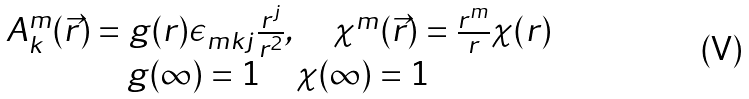Convert formula to latex. <formula><loc_0><loc_0><loc_500><loc_500>\begin{array} { c c } A _ { k } ^ { m } ( \vec { r } ) = g ( r ) \epsilon _ { m k j } \frac { r ^ { j } } { r ^ { 2 } } , \quad \chi ^ { m } ( \vec { r } ) = \frac { r ^ { m } } { r } \chi ( r ) \\ g ( \infty ) = 1 \quad \chi ( \infty ) = 1 \end{array}</formula> 